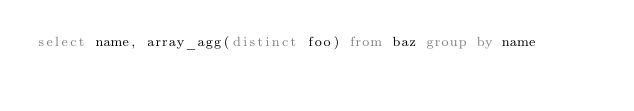<code> <loc_0><loc_0><loc_500><loc_500><_SQL_>select name, array_agg(distinct foo) from baz group by name
</code> 